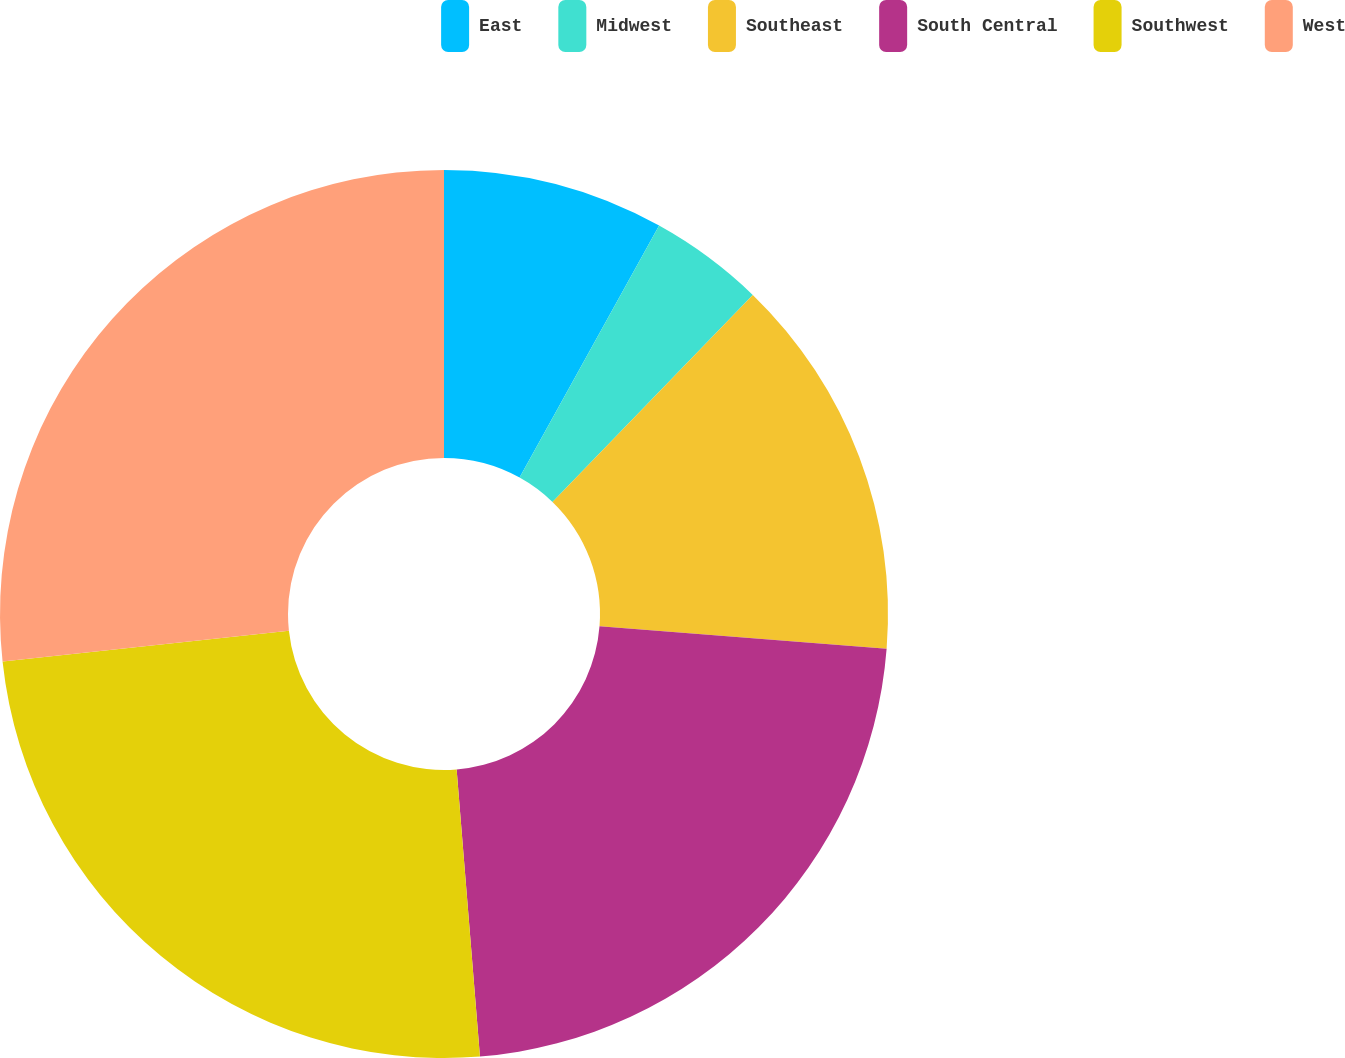Convert chart. <chart><loc_0><loc_0><loc_500><loc_500><pie_chart><fcel>East<fcel>Midwest<fcel>Southeast<fcel>South Central<fcel>Southwest<fcel>West<nl><fcel>8.05%<fcel>4.19%<fcel>14.01%<fcel>22.46%<fcel>24.58%<fcel>26.71%<nl></chart> 